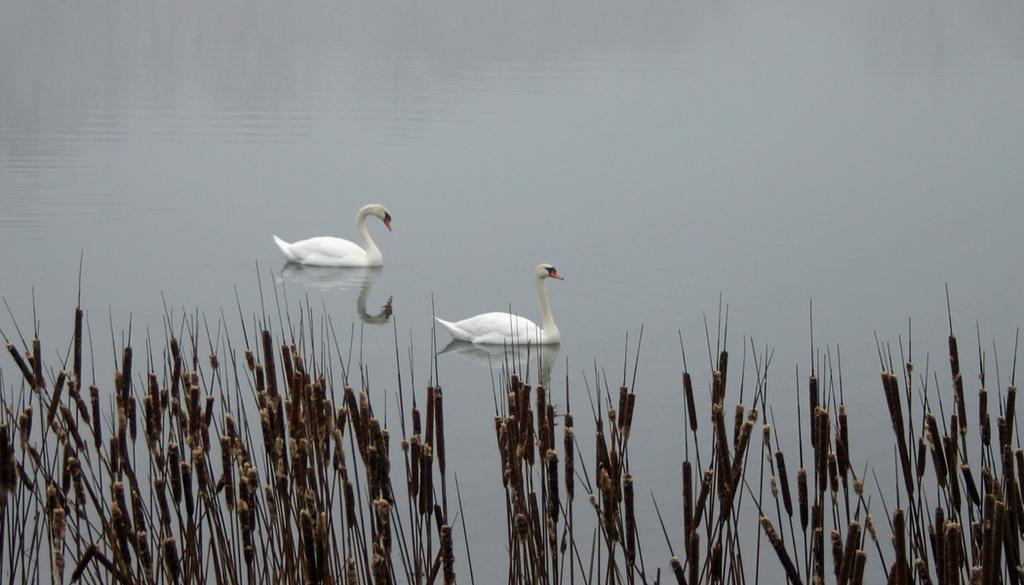What type of living organisms can be seen in the image? Plants and birds are visible in the image. How many birds are in the image? There are two birds in the image. Where are the birds located in relation to the water? The birds are on the water. What color are the birds? The birds are white in color. What type of comb is being used by the bird in the image? There is no comb present in the image, and the birds are not using any tools or accessories. 